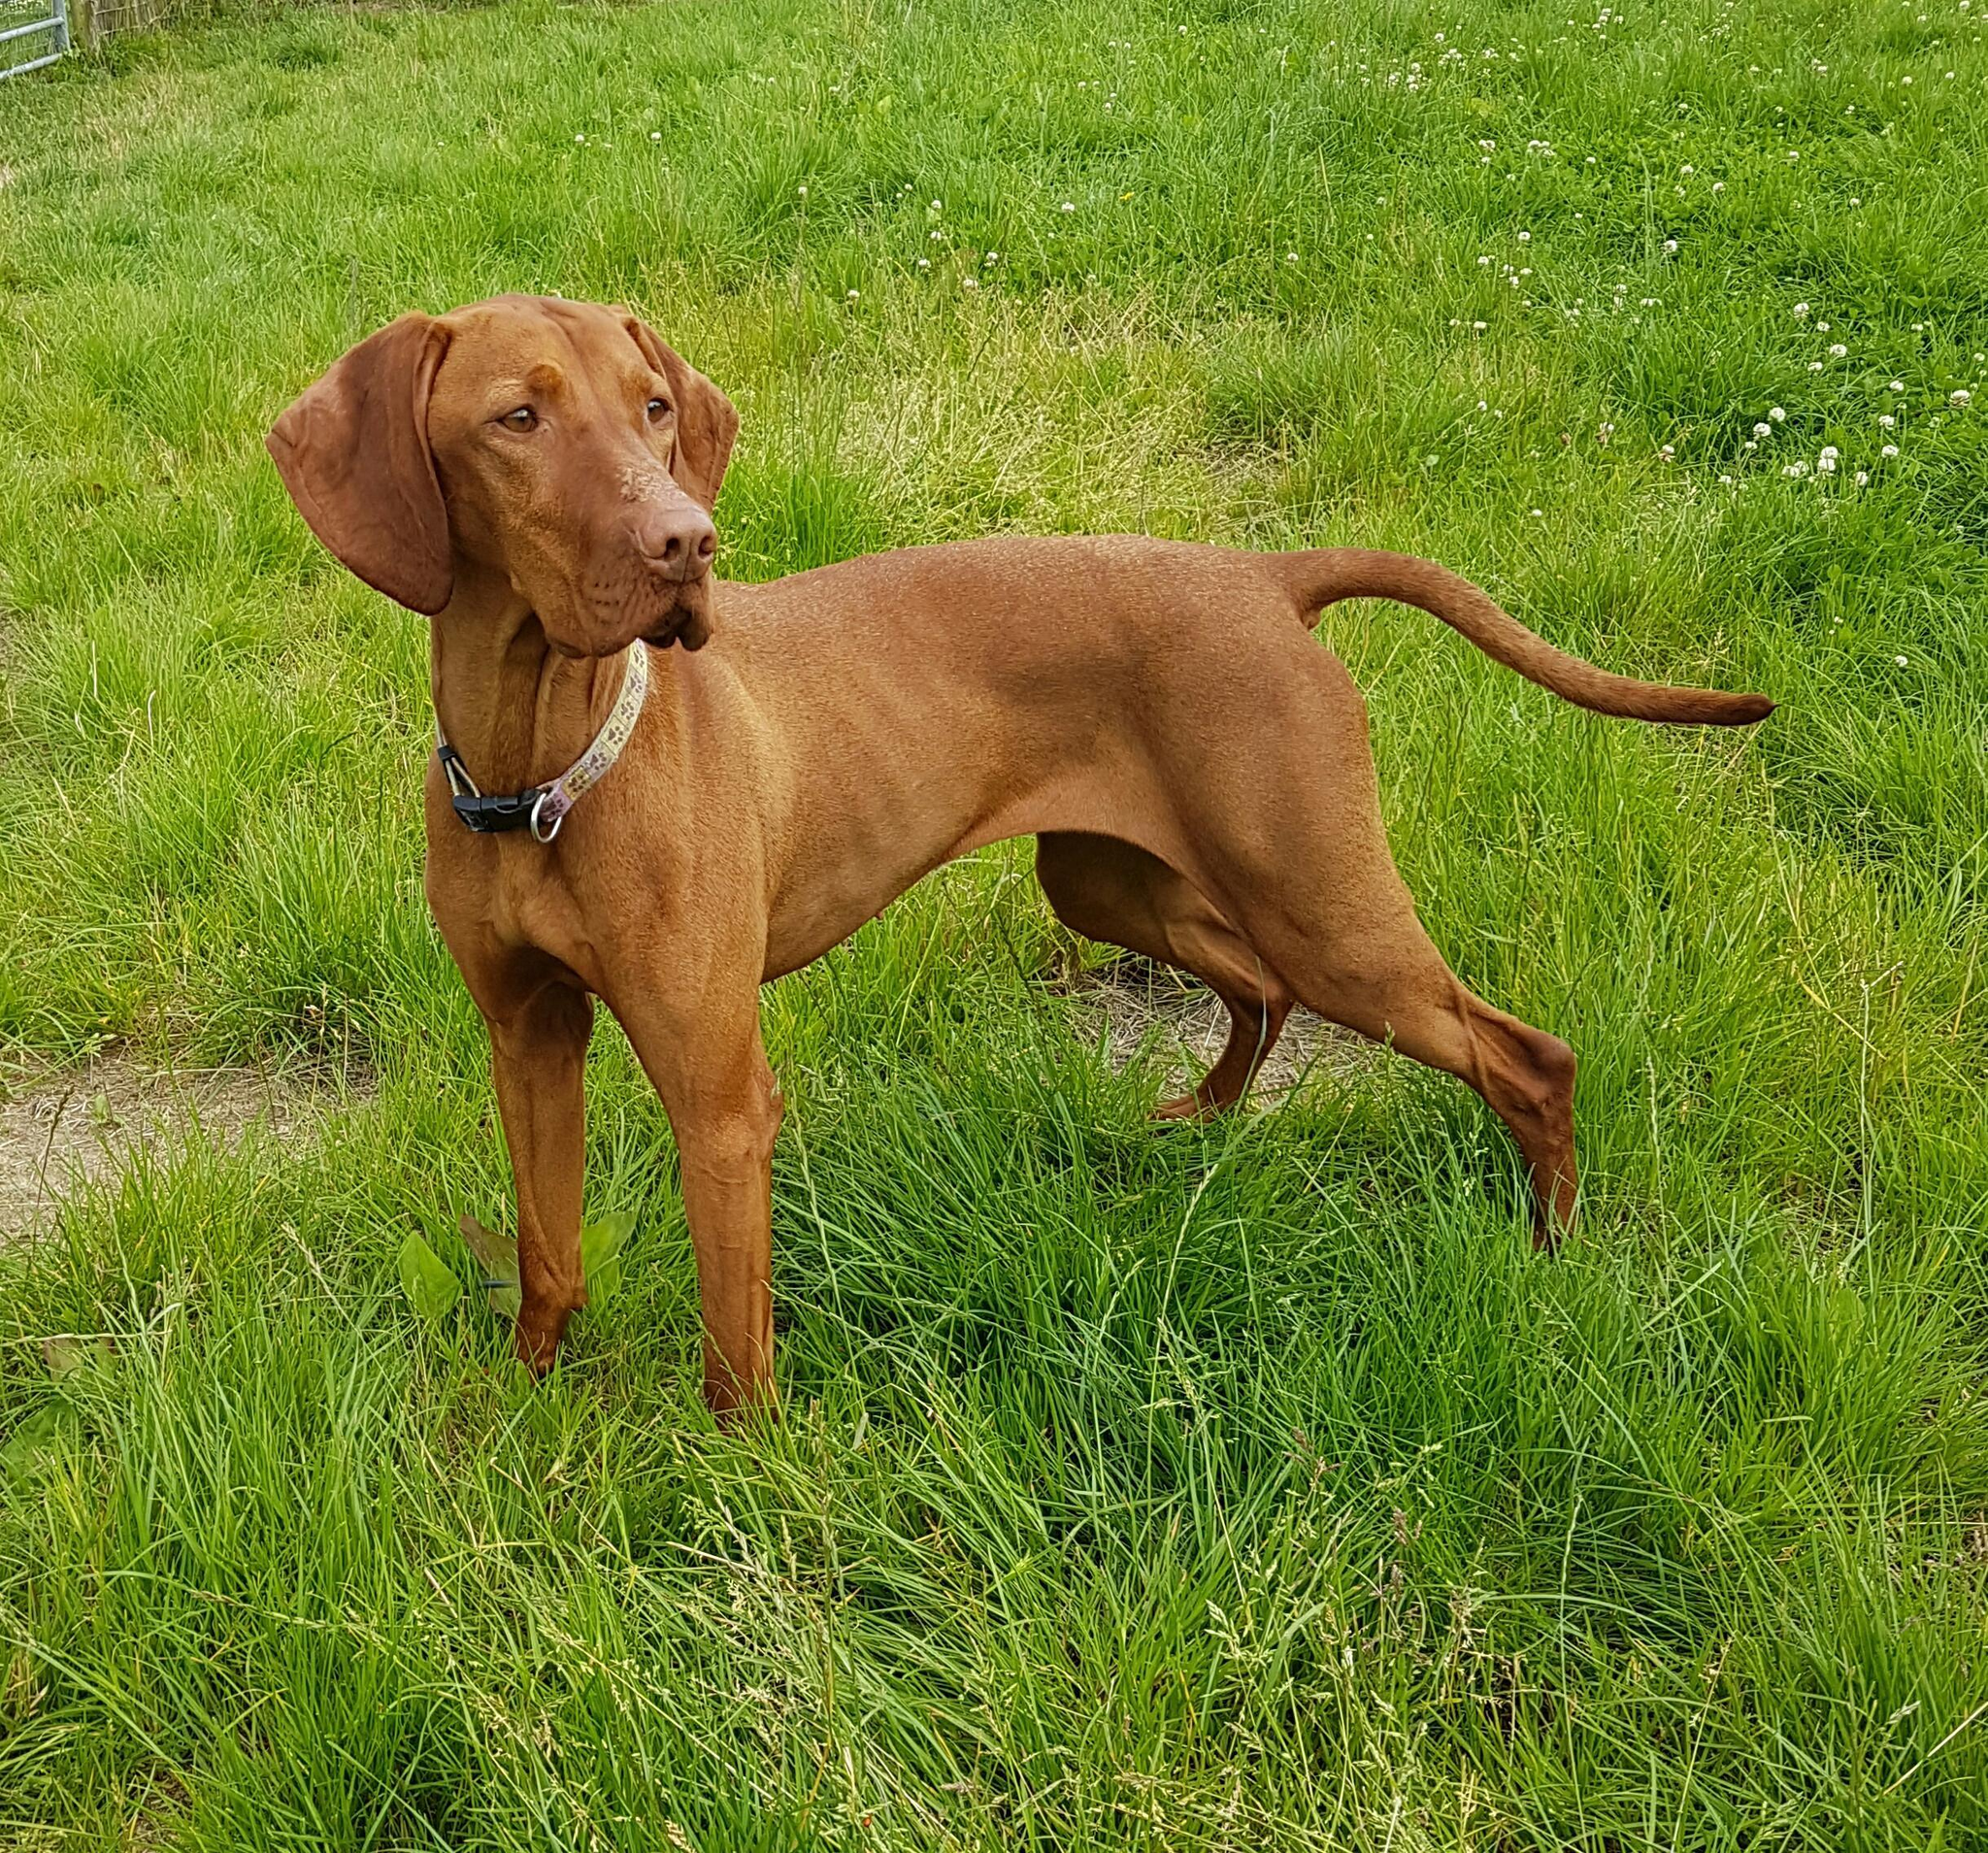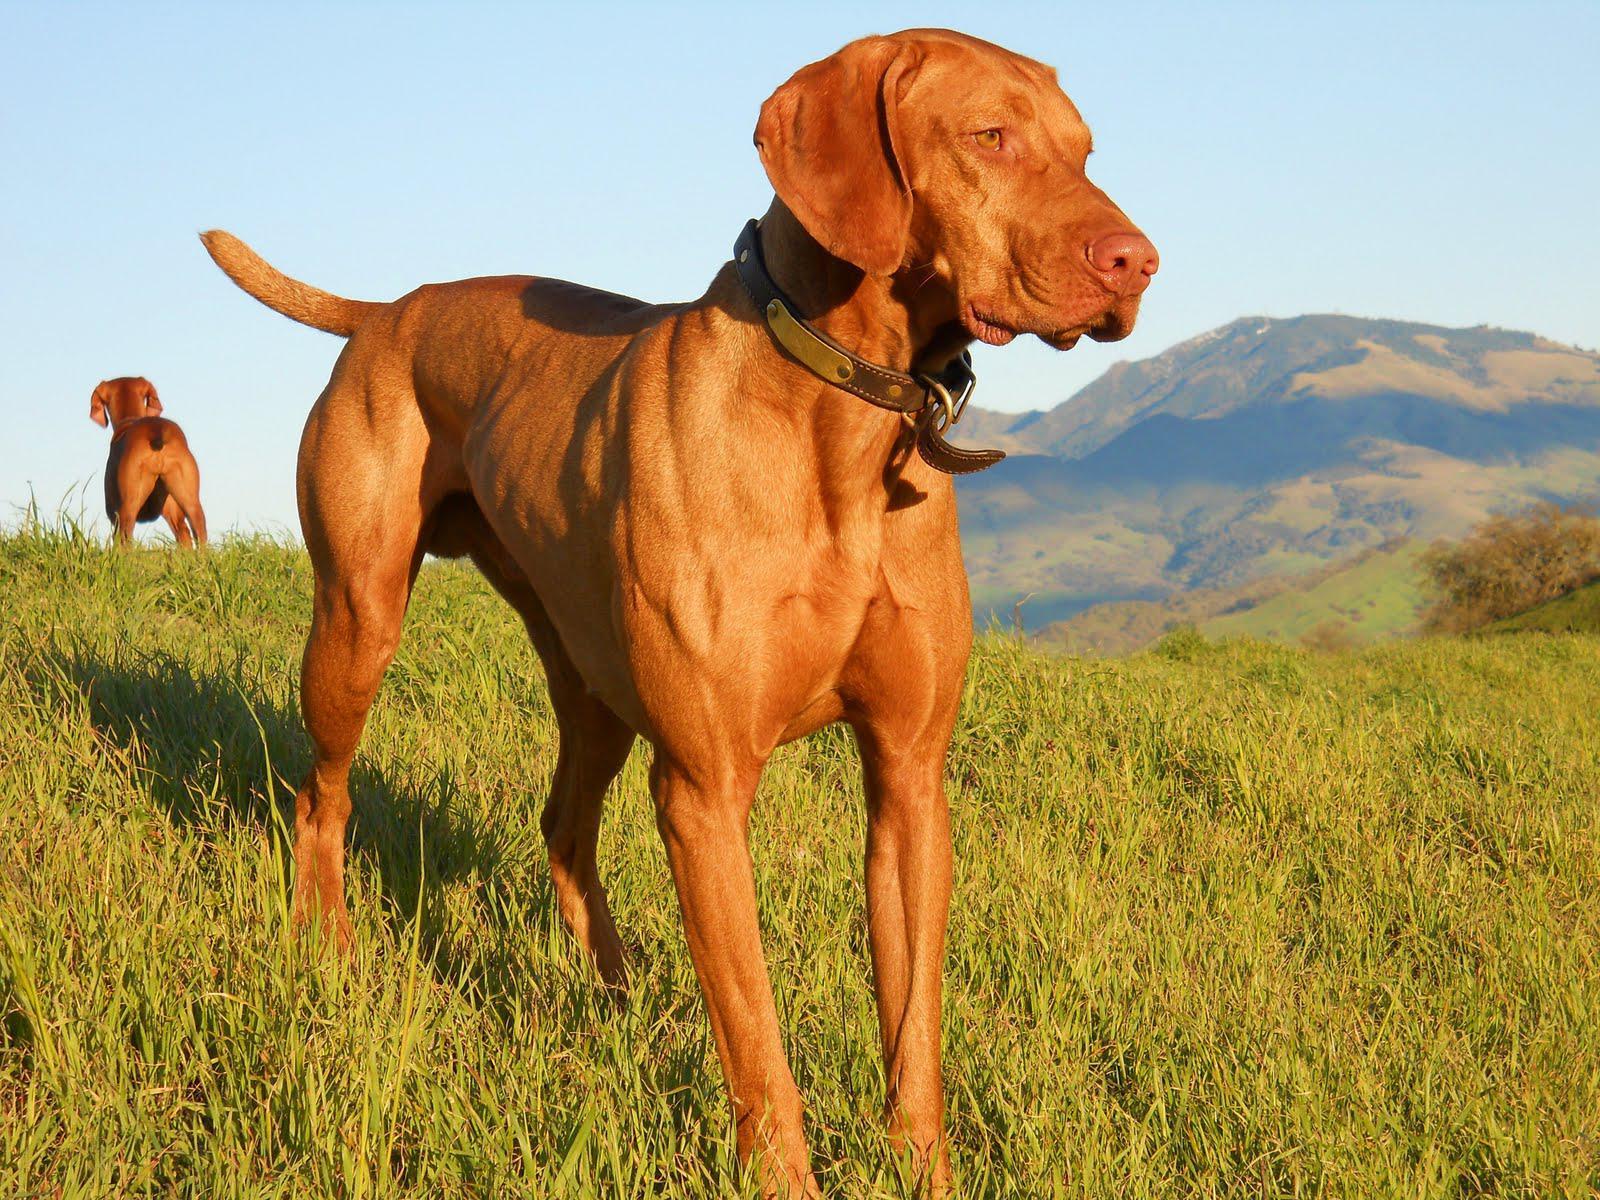The first image is the image on the left, the second image is the image on the right. Evaluate the accuracy of this statement regarding the images: "A dog is holding something in its mouth.". Is it true? Answer yes or no. No. The first image is the image on the left, the second image is the image on the right. Evaluate the accuracy of this statement regarding the images: "The dog on the left has something held in its mouth, and the dog on the right is standing on green grass with its tail extended.". Is it true? Answer yes or no. No. 